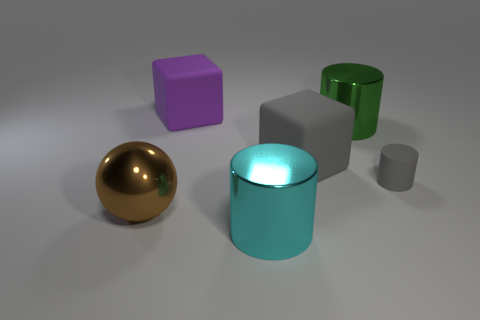Add 2 big gray things. How many objects exist? 8 Subtract all balls. How many objects are left? 5 Add 5 tiny brown cubes. How many tiny brown cubes exist? 5 Subtract 0 blue cylinders. How many objects are left? 6 Subtract all red matte spheres. Subtract all matte objects. How many objects are left? 3 Add 5 large cyan cylinders. How many large cyan cylinders are left? 6 